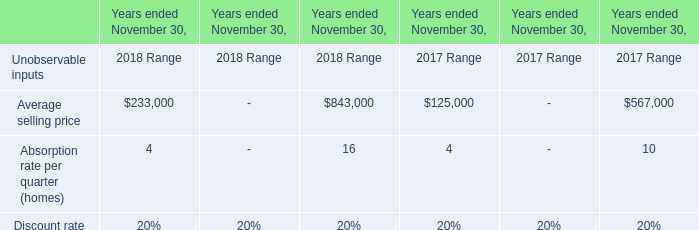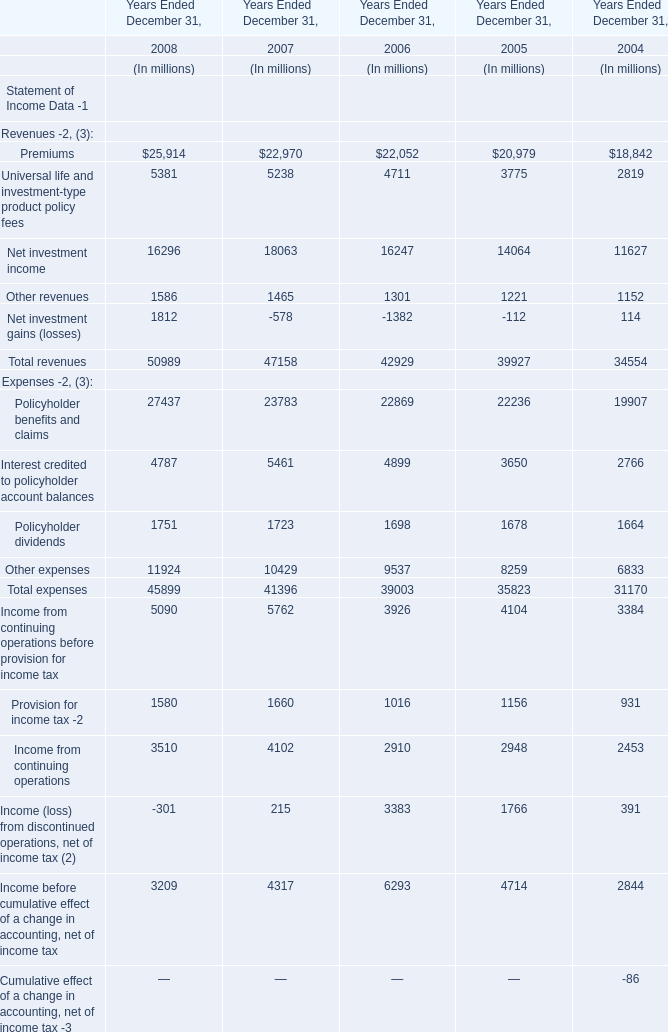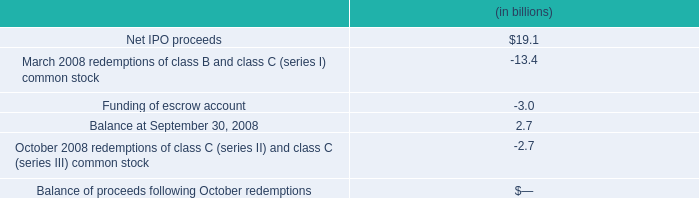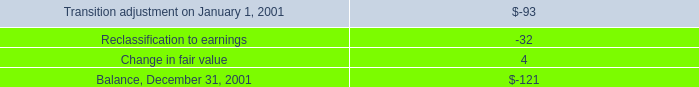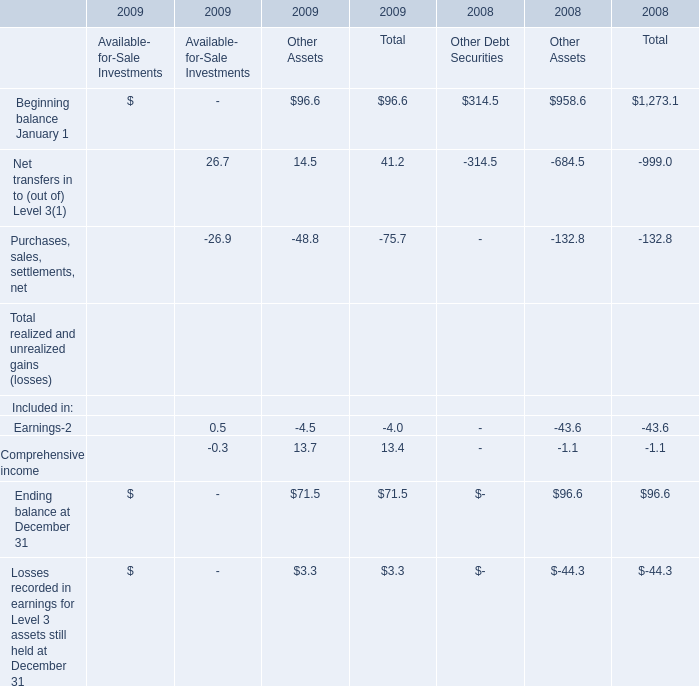What is the average value of Interest credited to policyholder account balances in 2007,2006 and 2005? (in million) 
Computations: (((5461 + 4899) + 3650) / 3)
Answer: 4670.0. 